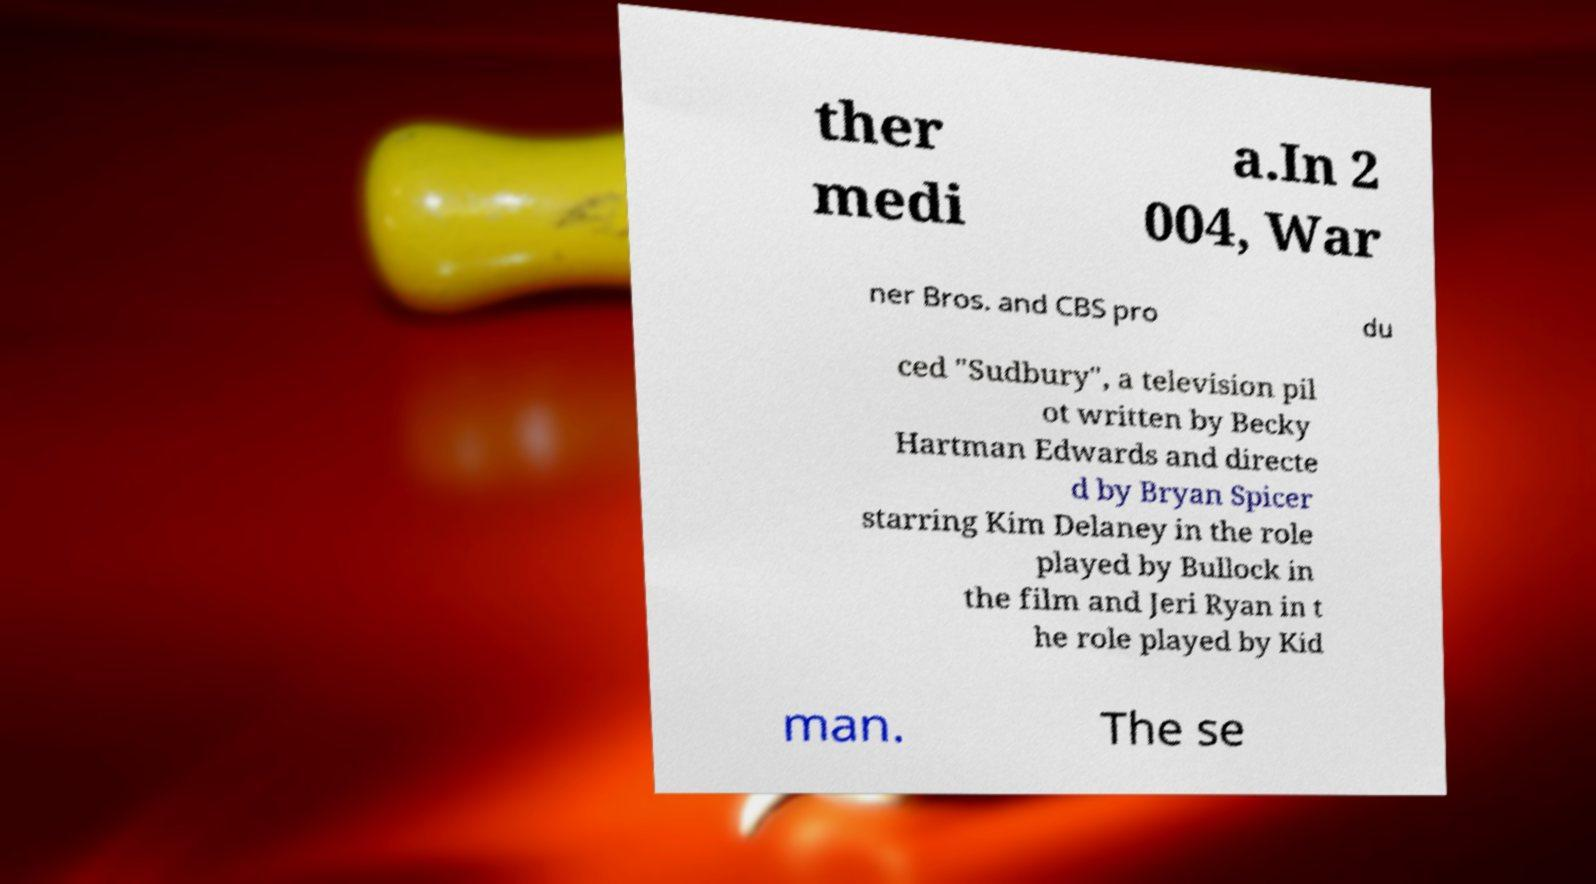Can you accurately transcribe the text from the provided image for me? ther medi a.In 2 004, War ner Bros. and CBS pro du ced "Sudbury", a television pil ot written by Becky Hartman Edwards and directe d by Bryan Spicer starring Kim Delaney in the role played by Bullock in the film and Jeri Ryan in t he role played by Kid man. The se 